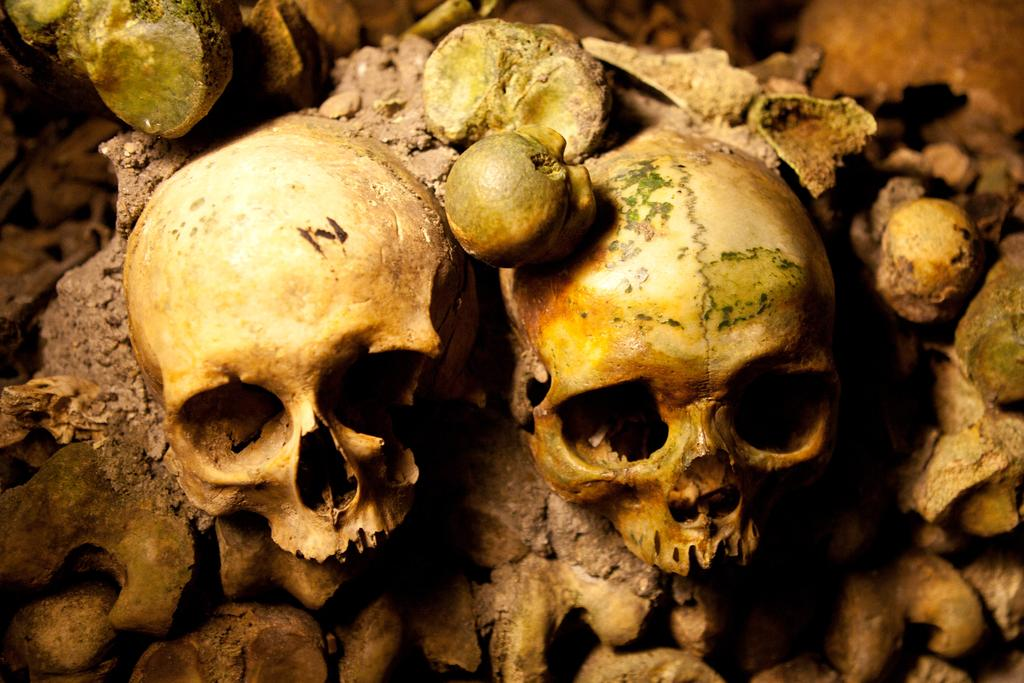What type of objects are present in the image? There are skulls and bones in the image. Can you describe the appearance of these objects? The skulls and bones are depicted in the image. What type of rifle is being used by the fireman in the image? There is no rifle or fireman present in the image; it only features skulls and bones. 